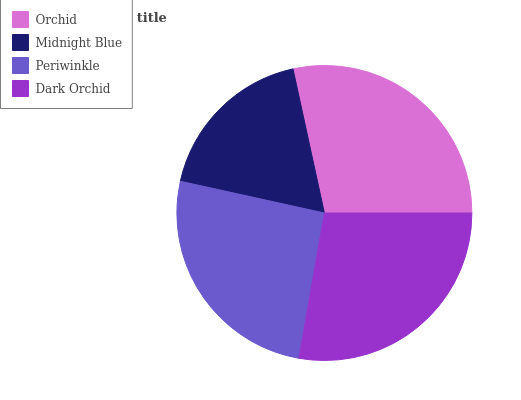Is Midnight Blue the minimum?
Answer yes or no. Yes. Is Orchid the maximum?
Answer yes or no. Yes. Is Periwinkle the minimum?
Answer yes or no. No. Is Periwinkle the maximum?
Answer yes or no. No. Is Periwinkle greater than Midnight Blue?
Answer yes or no. Yes. Is Midnight Blue less than Periwinkle?
Answer yes or no. Yes. Is Midnight Blue greater than Periwinkle?
Answer yes or no. No. Is Periwinkle less than Midnight Blue?
Answer yes or no. No. Is Dark Orchid the high median?
Answer yes or no. Yes. Is Periwinkle the low median?
Answer yes or no. Yes. Is Midnight Blue the high median?
Answer yes or no. No. Is Orchid the low median?
Answer yes or no. No. 